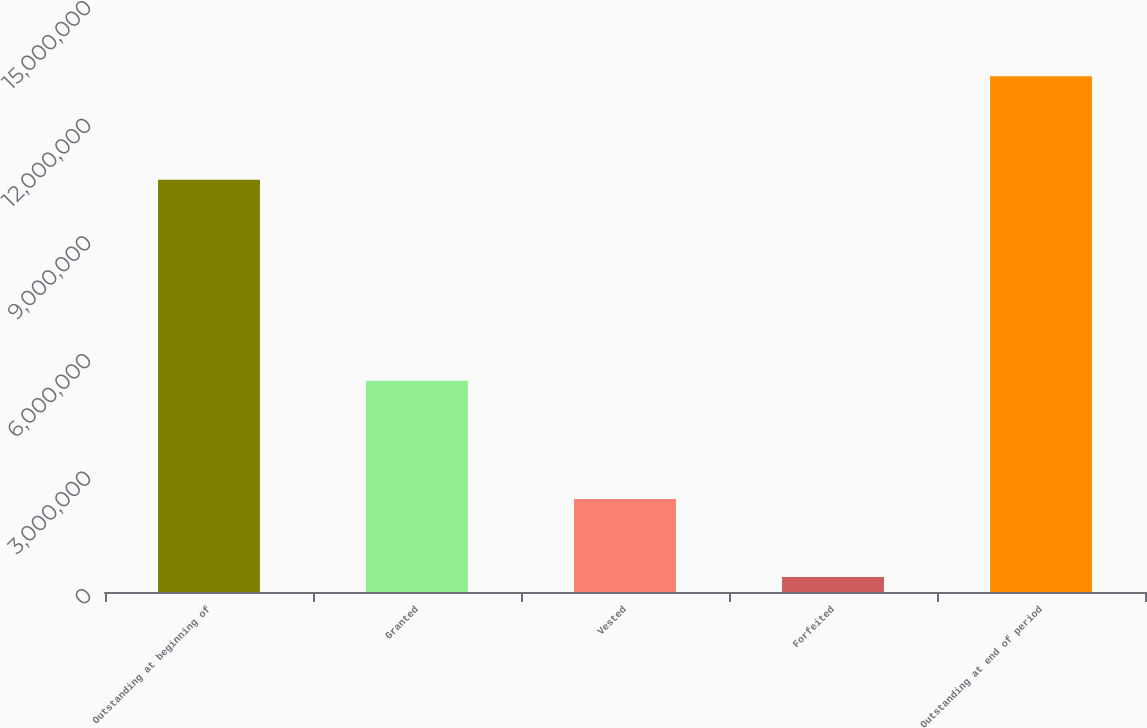Convert chart. <chart><loc_0><loc_0><loc_500><loc_500><bar_chart><fcel>Outstanding at beginning of<fcel>Granted<fcel>Vested<fcel>Forfeited<fcel>Outstanding at end of period<nl><fcel>1.05183e+07<fcel>5.38948e+06<fcel>2.37119e+06<fcel>382022<fcel>1.31546e+07<nl></chart> 